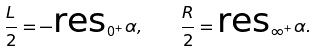Convert formula to latex. <formula><loc_0><loc_0><loc_500><loc_500>\frac { L } { 2 } = - \text {res} _ { 0 ^ { + } } \alpha , \quad \frac { R } { 2 } = \text {res} _ { \infty ^ { + } } \alpha .</formula> 